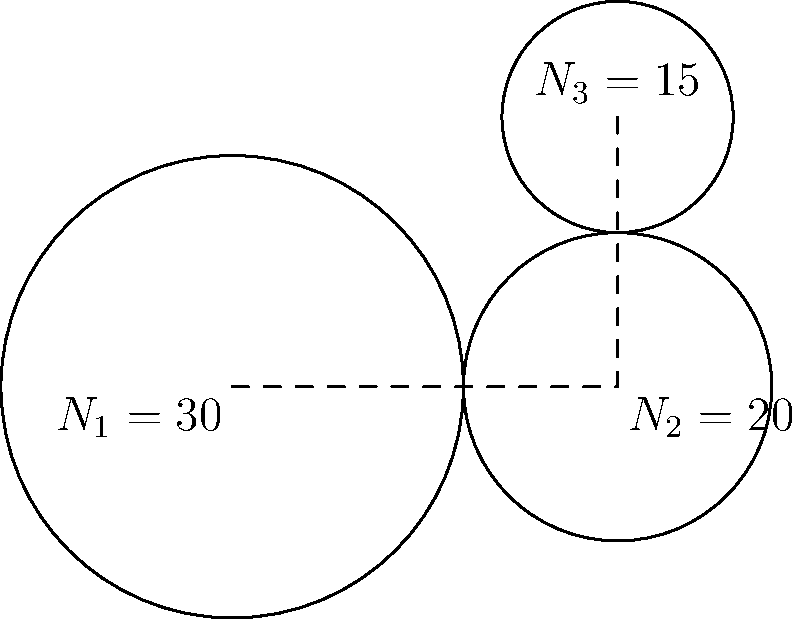In the simple gear train shown above, gear 1 (input) has 30 teeth and rotates at 1200 RPM clockwise. Gear 2 has 20 teeth, and gear 3 (output) has 15 teeth. Calculate the rotational speed and direction of gear 3. To solve this problem, we'll follow these steps:

1. Calculate the gear ratio between gear 1 and gear 2:
   $\text{Gear ratio}_{\text{1-2}} = \frac{N_1}{N_2} = \frac{30}{20} = 1.5$

2. Calculate the rotational speed of gear 2:
   $\omega_2 = \frac{\omega_1}{\text{Gear ratio}_{\text{1-2}}} = \frac{1200 \text{ RPM}}{1.5} = 800 \text{ RPM}$

3. Determine the direction of gear 2:
   Since gear 1 rotates clockwise, gear 2 will rotate counterclockwise.

4. Calculate the gear ratio between gear 2 and gear 3:
   $\text{Gear ratio}_{\text{2-3}} = \frac{N_2}{N_3} = \frac{20}{15} = \frac{4}{3}$

5. Calculate the rotational speed of gear 3:
   $\omega_3 = \frac{\omega_2}{\text{Gear ratio}_{\text{2-3}}} = \frac{800 \text{ RPM}}{\frac{4}{3}} = 600 \text{ RPM}$

6. Determine the direction of gear 3:
   Since gear 2 rotates counterclockwise, gear 3 will rotate clockwise.

Therefore, gear 3 rotates at 600 RPM in the clockwise direction.
Answer: 600 RPM clockwise 